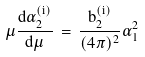<formula> <loc_0><loc_0><loc_500><loc_500>\mu { \frac { d \alpha _ { 2 } ^ { ( i ) } } { d \mu } } \, = \, { \frac { b _ { 2 } ^ { ( i ) } } { ( 4 \pi ) ^ { 2 } } } \alpha _ { 1 } ^ { 2 }</formula> 